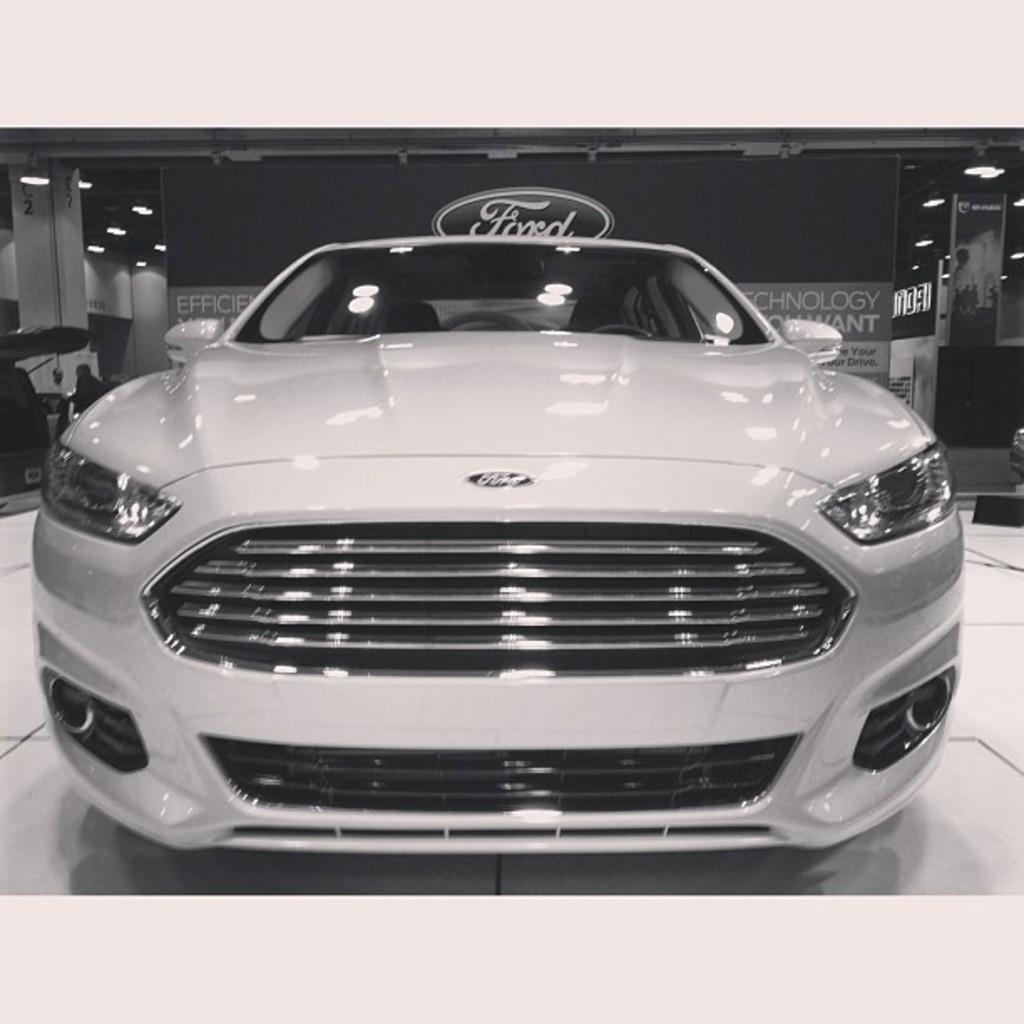Please provide a concise description of this image. In this image we can see a vehicle on the floor, there are some lights, pillars and a board, on the board we can see the text. 